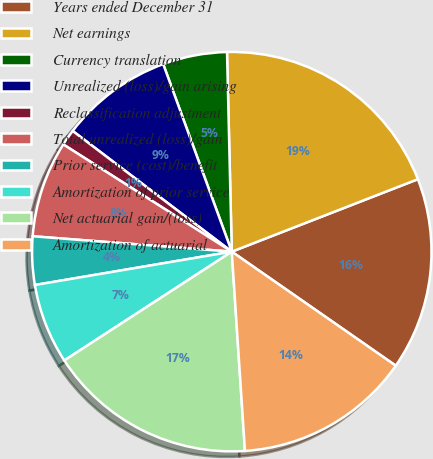Convert chart to OTSL. <chart><loc_0><loc_0><loc_500><loc_500><pie_chart><fcel>Years ended December 31<fcel>Net earnings<fcel>Currency translation<fcel>Unrealized (loss)/gain arising<fcel>Reclassification adjustment<fcel>Total unrealized (loss)/gain<fcel>Prior service (cost)/benefit<fcel>Amortization of prior service<fcel>Net actuarial gain/(loss)<fcel>Amortization of actuarial<nl><fcel>15.58%<fcel>19.47%<fcel>5.2%<fcel>9.09%<fcel>1.31%<fcel>7.79%<fcel>3.9%<fcel>6.5%<fcel>16.88%<fcel>14.28%<nl></chart> 